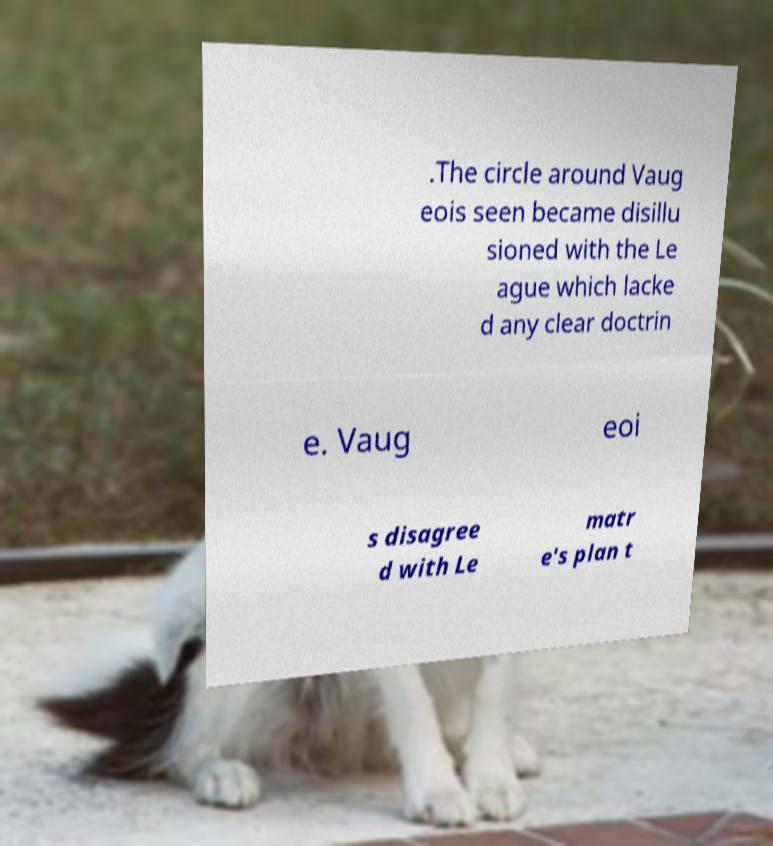I need the written content from this picture converted into text. Can you do that? .The circle around Vaug eois seen became disillu sioned with the Le ague which lacke d any clear doctrin e. Vaug eoi s disagree d with Le matr e's plan t 